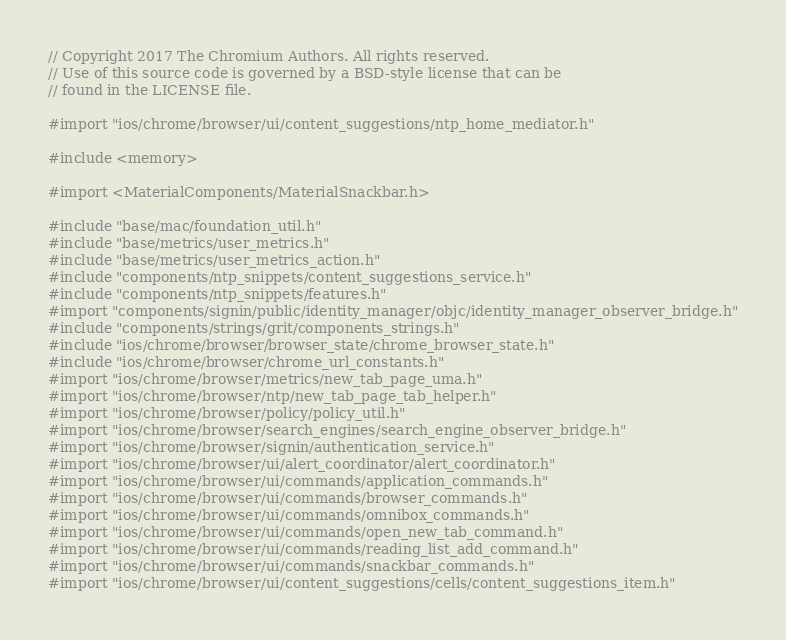<code> <loc_0><loc_0><loc_500><loc_500><_ObjectiveC_>// Copyright 2017 The Chromium Authors. All rights reserved.
// Use of this source code is governed by a BSD-style license that can be
// found in the LICENSE file.

#import "ios/chrome/browser/ui/content_suggestions/ntp_home_mediator.h"

#include <memory>

#import <MaterialComponents/MaterialSnackbar.h>

#include "base/mac/foundation_util.h"
#include "base/metrics/user_metrics.h"
#include "base/metrics/user_metrics_action.h"
#include "components/ntp_snippets/content_suggestions_service.h"
#include "components/ntp_snippets/features.h"
#import "components/signin/public/identity_manager/objc/identity_manager_observer_bridge.h"
#include "components/strings/grit/components_strings.h"
#include "ios/chrome/browser/browser_state/chrome_browser_state.h"
#include "ios/chrome/browser/chrome_url_constants.h"
#import "ios/chrome/browser/metrics/new_tab_page_uma.h"
#import "ios/chrome/browser/ntp/new_tab_page_tab_helper.h"
#import "ios/chrome/browser/policy/policy_util.h"
#import "ios/chrome/browser/search_engines/search_engine_observer_bridge.h"
#import "ios/chrome/browser/signin/authentication_service.h"
#import "ios/chrome/browser/ui/alert_coordinator/alert_coordinator.h"
#import "ios/chrome/browser/ui/commands/application_commands.h"
#import "ios/chrome/browser/ui/commands/browser_commands.h"
#import "ios/chrome/browser/ui/commands/omnibox_commands.h"
#import "ios/chrome/browser/ui/commands/open_new_tab_command.h"
#import "ios/chrome/browser/ui/commands/reading_list_add_command.h"
#import "ios/chrome/browser/ui/commands/snackbar_commands.h"
#import "ios/chrome/browser/ui/content_suggestions/cells/content_suggestions_item.h"</code> 